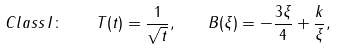Convert formula to latex. <formula><loc_0><loc_0><loc_500><loc_500>C l a s s \, I \colon \quad T ( t ) = \frac { 1 } { \sqrt { t } } , \quad B ( \xi ) = - \frac { 3 \xi } { 4 } + \frac { k } { \xi } ,</formula> 